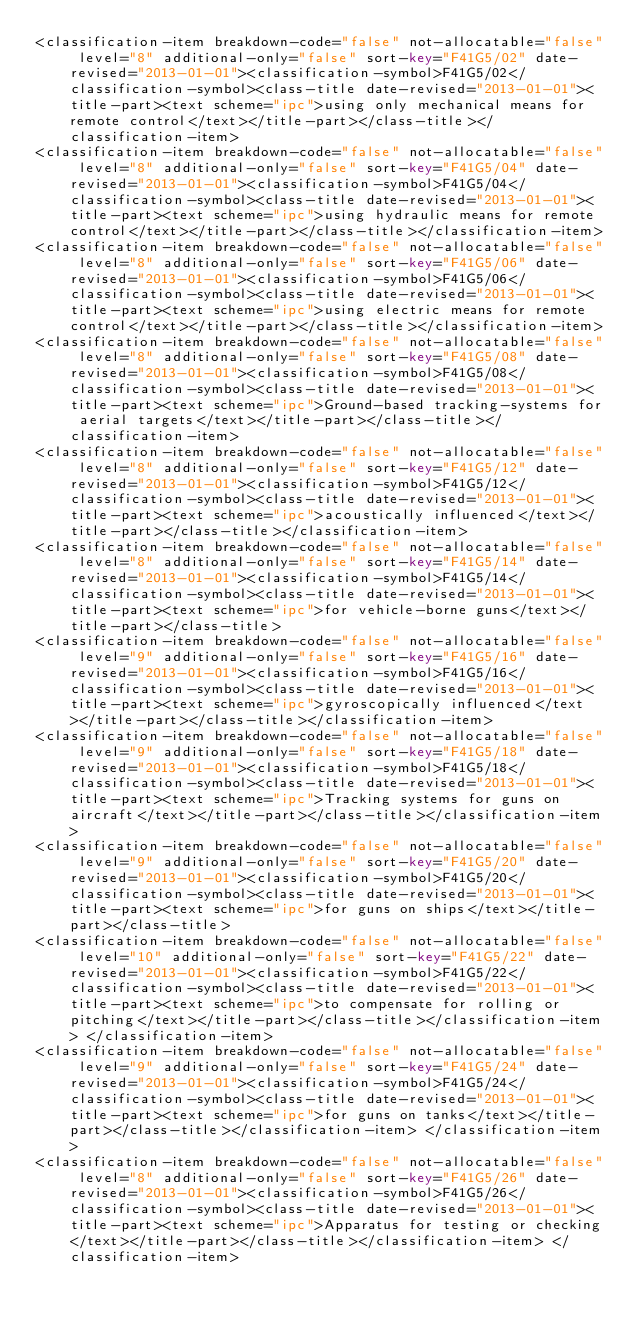<code> <loc_0><loc_0><loc_500><loc_500><_XML_><classification-item breakdown-code="false" not-allocatable="false" level="8" additional-only="false" sort-key="F41G5/02" date-revised="2013-01-01"><classification-symbol>F41G5/02</classification-symbol><class-title date-revised="2013-01-01"><title-part><text scheme="ipc">using only mechanical means for remote control</text></title-part></class-title></classification-item> 
<classification-item breakdown-code="false" not-allocatable="false" level="8" additional-only="false" sort-key="F41G5/04" date-revised="2013-01-01"><classification-symbol>F41G5/04</classification-symbol><class-title date-revised="2013-01-01"><title-part><text scheme="ipc">using hydraulic means for remote control</text></title-part></class-title></classification-item> 
<classification-item breakdown-code="false" not-allocatable="false" level="8" additional-only="false" sort-key="F41G5/06" date-revised="2013-01-01"><classification-symbol>F41G5/06</classification-symbol><class-title date-revised="2013-01-01"><title-part><text scheme="ipc">using electric means for remote control</text></title-part></class-title></classification-item> 
<classification-item breakdown-code="false" not-allocatable="false" level="8" additional-only="false" sort-key="F41G5/08" date-revised="2013-01-01"><classification-symbol>F41G5/08</classification-symbol><class-title date-revised="2013-01-01"><title-part><text scheme="ipc">Ground-based tracking-systems for aerial targets</text></title-part></class-title></classification-item> 
<classification-item breakdown-code="false" not-allocatable="false" level="8" additional-only="false" sort-key="F41G5/12" date-revised="2013-01-01"><classification-symbol>F41G5/12</classification-symbol><class-title date-revised="2013-01-01"><title-part><text scheme="ipc">acoustically influenced</text></title-part></class-title></classification-item> 
<classification-item breakdown-code="false" not-allocatable="false" level="8" additional-only="false" sort-key="F41G5/14" date-revised="2013-01-01"><classification-symbol>F41G5/14</classification-symbol><class-title date-revised="2013-01-01"><title-part><text scheme="ipc">for vehicle-borne guns</text></title-part></class-title> 
<classification-item breakdown-code="false" not-allocatable="false" level="9" additional-only="false" sort-key="F41G5/16" date-revised="2013-01-01"><classification-symbol>F41G5/16</classification-symbol><class-title date-revised="2013-01-01"><title-part><text scheme="ipc">gyroscopically influenced</text></title-part></class-title></classification-item> 
<classification-item breakdown-code="false" not-allocatable="false" level="9" additional-only="false" sort-key="F41G5/18" date-revised="2013-01-01"><classification-symbol>F41G5/18</classification-symbol><class-title date-revised="2013-01-01"><title-part><text scheme="ipc">Tracking systems for guns on aircraft</text></title-part></class-title></classification-item> 
<classification-item breakdown-code="false" not-allocatable="false" level="9" additional-only="false" sort-key="F41G5/20" date-revised="2013-01-01"><classification-symbol>F41G5/20</classification-symbol><class-title date-revised="2013-01-01"><title-part><text scheme="ipc">for guns on ships</text></title-part></class-title> 
<classification-item breakdown-code="false" not-allocatable="false" level="10" additional-only="false" sort-key="F41G5/22" date-revised="2013-01-01"><classification-symbol>F41G5/22</classification-symbol><class-title date-revised="2013-01-01"><title-part><text scheme="ipc">to compensate for rolling or pitching</text></title-part></class-title></classification-item> </classification-item> 
<classification-item breakdown-code="false" not-allocatable="false" level="9" additional-only="false" sort-key="F41G5/24" date-revised="2013-01-01"><classification-symbol>F41G5/24</classification-symbol><class-title date-revised="2013-01-01"><title-part><text scheme="ipc">for guns on tanks</text></title-part></class-title></classification-item> </classification-item> 
<classification-item breakdown-code="false" not-allocatable="false" level="8" additional-only="false" sort-key="F41G5/26" date-revised="2013-01-01"><classification-symbol>F41G5/26</classification-symbol><class-title date-revised="2013-01-01"><title-part><text scheme="ipc">Apparatus for testing or checking</text></title-part></class-title></classification-item> </classification-item> </code> 